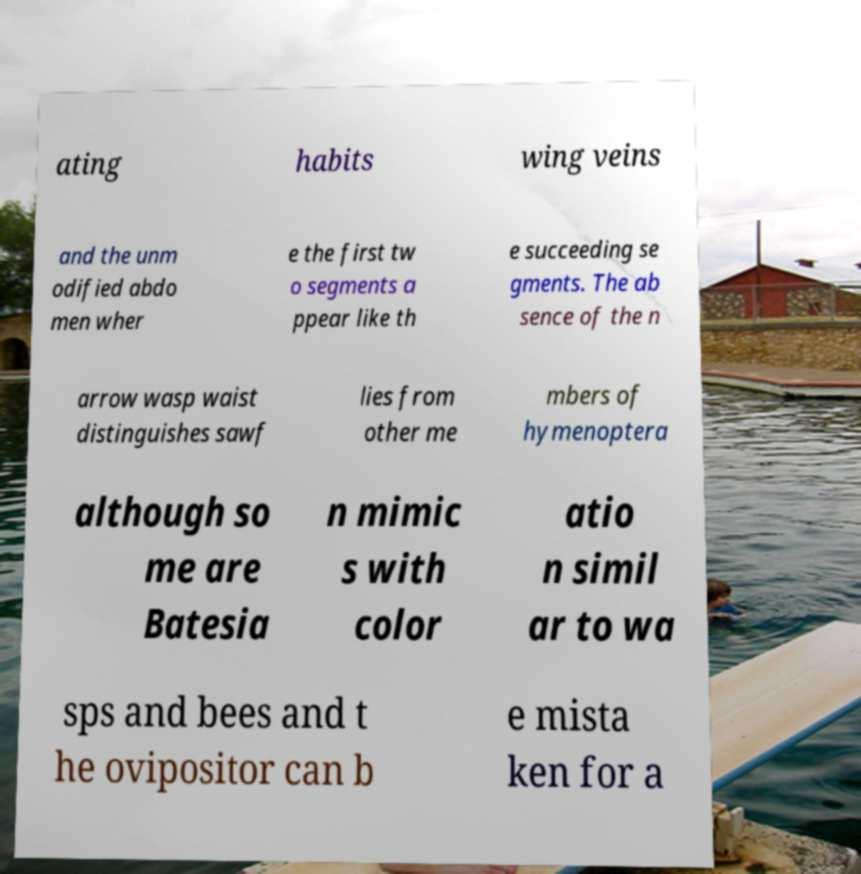There's text embedded in this image that I need extracted. Can you transcribe it verbatim? ating habits wing veins and the unm odified abdo men wher e the first tw o segments a ppear like th e succeeding se gments. The ab sence of the n arrow wasp waist distinguishes sawf lies from other me mbers of hymenoptera although so me are Batesia n mimic s with color atio n simil ar to wa sps and bees and t he ovipositor can b e mista ken for a 